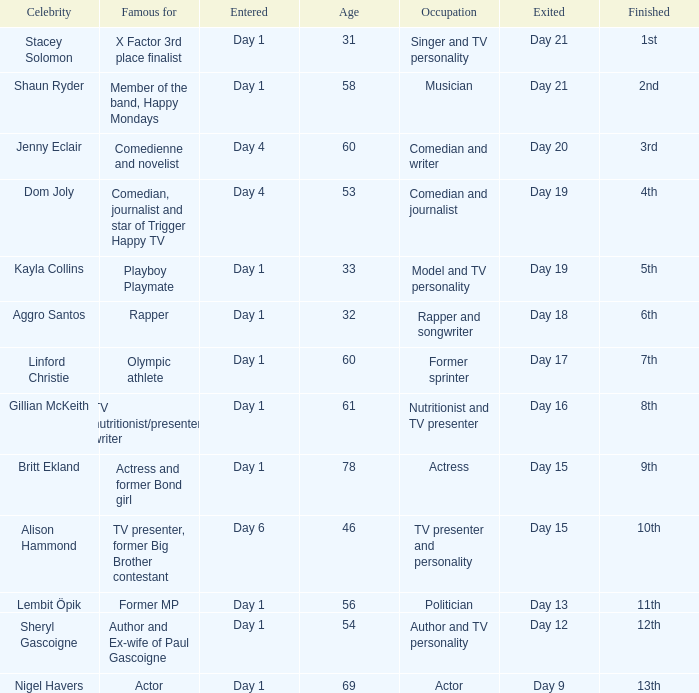Which celebrity was famous for being a rapper? Aggro Santos. 